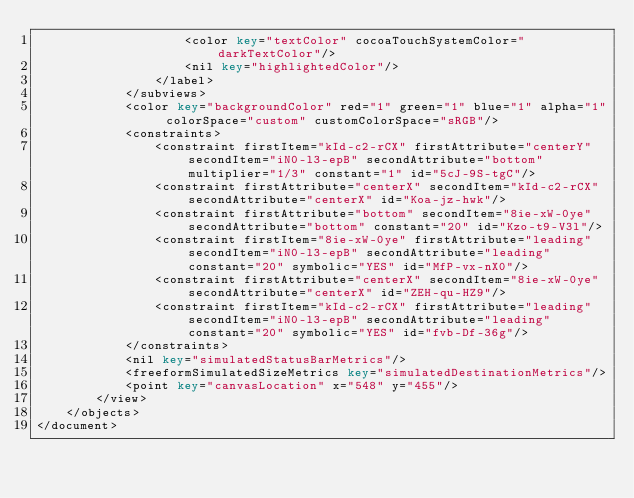Convert code to text. <code><loc_0><loc_0><loc_500><loc_500><_XML_>                    <color key="textColor" cocoaTouchSystemColor="darkTextColor"/>
                    <nil key="highlightedColor"/>
                </label>
            </subviews>
            <color key="backgroundColor" red="1" green="1" blue="1" alpha="1" colorSpace="custom" customColorSpace="sRGB"/>
            <constraints>
                <constraint firstItem="kId-c2-rCX" firstAttribute="centerY" secondItem="iN0-l3-epB" secondAttribute="bottom" multiplier="1/3" constant="1" id="5cJ-9S-tgC"/>
                <constraint firstAttribute="centerX" secondItem="kId-c2-rCX" secondAttribute="centerX" id="Koa-jz-hwk"/>
                <constraint firstAttribute="bottom" secondItem="8ie-xW-0ye" secondAttribute="bottom" constant="20" id="Kzo-t9-V3l"/>
                <constraint firstItem="8ie-xW-0ye" firstAttribute="leading" secondItem="iN0-l3-epB" secondAttribute="leading" constant="20" symbolic="YES" id="MfP-vx-nX0"/>
                <constraint firstAttribute="centerX" secondItem="8ie-xW-0ye" secondAttribute="centerX" id="ZEH-qu-HZ9"/>
                <constraint firstItem="kId-c2-rCX" firstAttribute="leading" secondItem="iN0-l3-epB" secondAttribute="leading" constant="20" symbolic="YES" id="fvb-Df-36g"/>
            </constraints>
            <nil key="simulatedStatusBarMetrics"/>
            <freeformSimulatedSizeMetrics key="simulatedDestinationMetrics"/>
            <point key="canvasLocation" x="548" y="455"/>
        </view>
    </objects>
</document>
</code> 